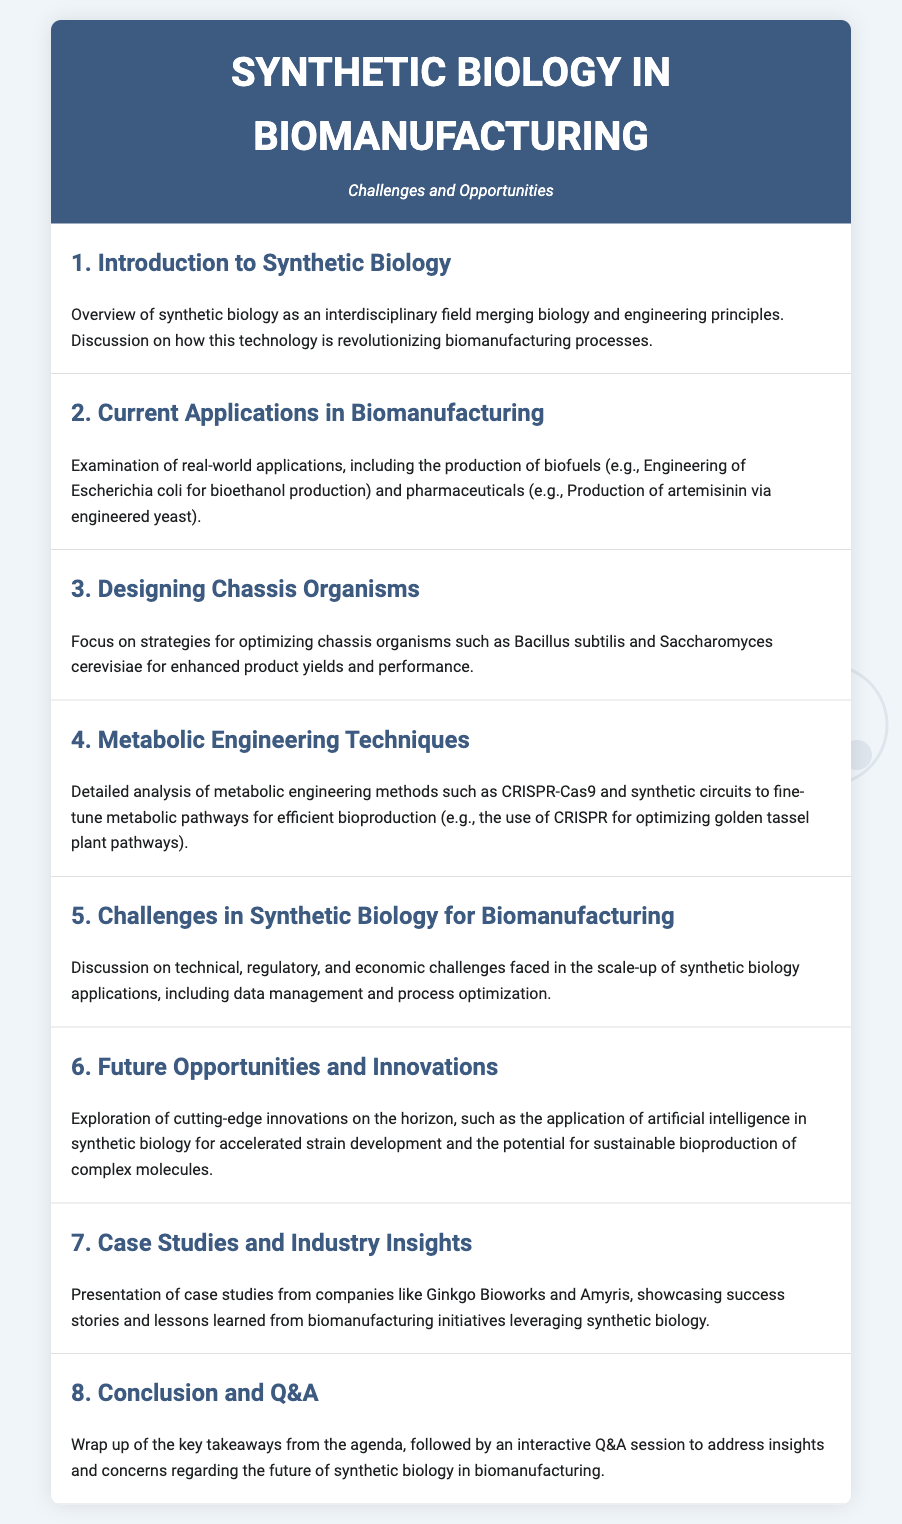What is the title of the agenda? The title of the agenda can be found at the top of the document, which is about synthetic biology in biomanufacturing.
Answer: Synthetic Biology in Biomanufacturing Who is the target audience for the Q&A session? The Q&A session is intended for participants seeking insights and addressing concerns regarding the agenda's topic.
Answer: Attendees What organism is engineered for bioethanol production? The agenda discusses a specific organism used for producing bioethanol in biomanufacturing applications.
Answer: Escherichia coli Which metabolic engineering technique is highlighted for optimizing pathways? One particular method for refining metabolic pathways is emphasized in the agenda items relating to metabolic engineering.
Answer: CRISPR-Cas9 What is a key challenge in synthetic biology discussed in the document? The text outlines several challenges, with a specific focus on one major issue in the scale-up of applications in synthetic biology.
Answer: Regulatory Name one company mentioned in the case studies. The case studies presented include examples from specific companies that utilize synthetic biology in their processes.
Answer: Ginkgo Bioworks What is one future opportunity in synthetic biology mentioned? Potential advancements and future possibilities in the field of synthetic biology are explored in the agenda.
Answer: Artificial intelligence How many agenda items are included in the document? The number of distinct items that focus on various aspects of synthetic biology and biomanufacturing is specified.
Answer: Eight 